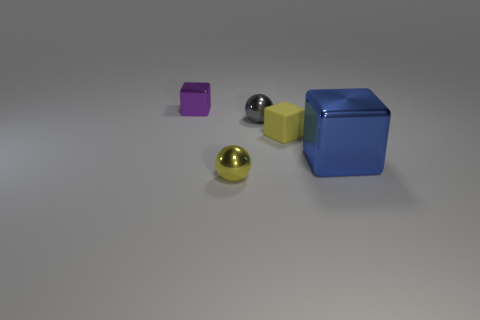There is a yellow shiny sphere; is its size the same as the metallic block right of the purple shiny cube?
Your response must be concise. No. There is a metallic thing that is on the right side of the tiny yellow thing that is behind the ball in front of the blue thing; what is its size?
Provide a short and direct response. Large. How many rubber objects are tiny purple things or tiny things?
Your answer should be compact. 1. What color is the small sphere in front of the tiny gray metal object?
Your response must be concise. Yellow. What is the shape of the purple object that is the same size as the gray metal object?
Ensure brevity in your answer.  Cube. There is a tiny rubber cube; does it have the same color as the cube that is left of the tiny gray metal sphere?
Keep it short and to the point. No. What number of things are yellow things that are in front of the rubber thing or metallic things on the right side of the gray sphere?
Ensure brevity in your answer.  2. There is a purple block that is the same size as the gray metallic ball; what material is it?
Your response must be concise. Metal. How many other things are made of the same material as the yellow sphere?
Your response must be concise. 3. Does the small gray thing that is behind the tiny rubber block have the same shape as the small metal object in front of the large blue shiny block?
Offer a very short reply. Yes. 